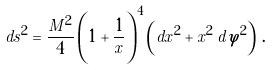Convert formula to latex. <formula><loc_0><loc_0><loc_500><loc_500>d s ^ { 2 } = \frac { M ^ { 2 } } { 4 } \left ( 1 + \frac { 1 } { x } \right ) ^ { 4 } \left ( d x ^ { 2 } + x ^ { 2 } \, d \varphi ^ { 2 } \right ) \, .</formula> 